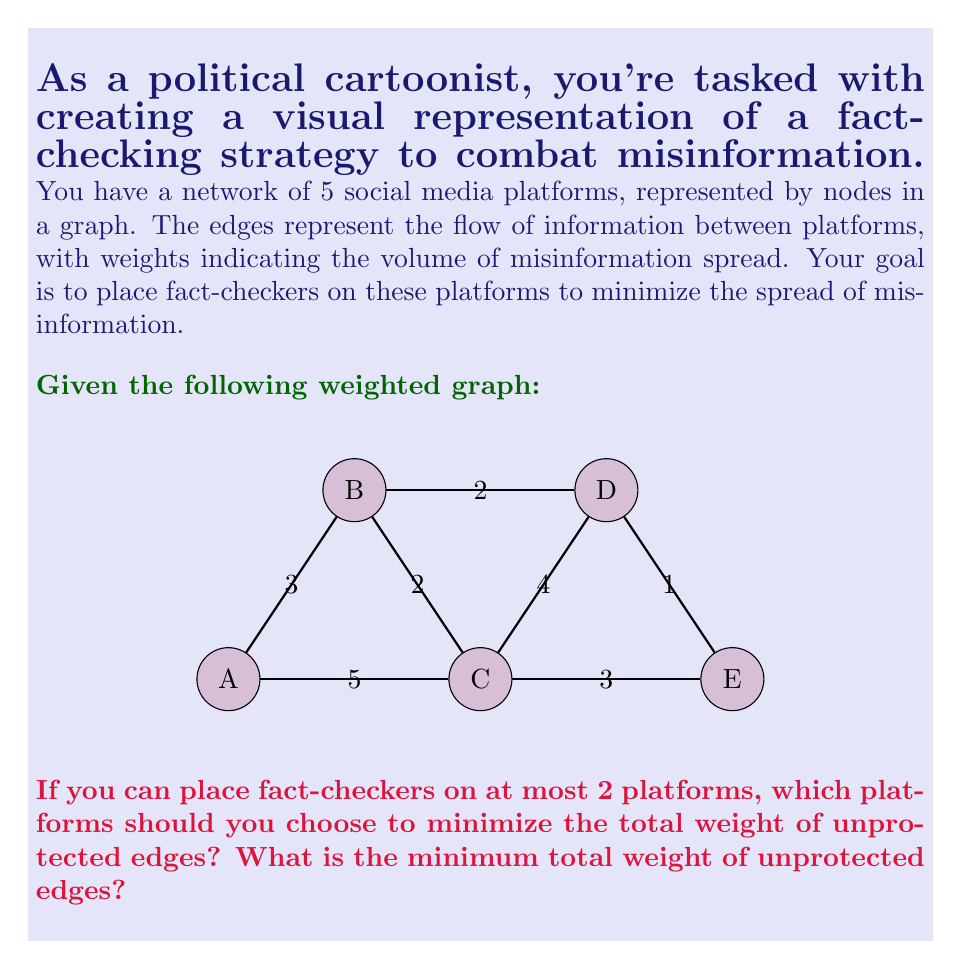Can you answer this question? Let's approach this step-by-step:

1) First, we need to understand what "unprotected edges" means. An edge is considered protected if at least one of its endpoints (nodes) has a fact-checker.

2) We need to consider all possible combinations of placing fact-checkers on 2 platforms out of 5. There are $\binom{5}{2} = 10$ such combinations.

3) For each combination, we'll calculate the total weight of unprotected edges:

   AB: 3-2 = 1 (BC, CD, DE unprotected)
   AC: 3+2+1 = 6 (BD, DE unprotected)
   AD: 3+5+3+1 = 12 (BC, CE unprotected)
   AE: 3+2+4+2 = 11 (BC, BD unprotected)
   BC: 3+4+1 = 8 (AE unprotected)
   BD: 3+5+3+1 = 12 (AC, CE unprotected)
   BE: 3+5+4+2 = 14 (AC unprotected)
   CD: 3+5+1 = 9 (AB, DE unprotected)
   CE: 3+2+2 = 7 (AB, BD unprotected)
   DE: 3+5+4+2 = 14 (AC unprotected)

4) The minimum total weight of unprotected edges is 1, which occurs when fact-checkers are placed on platforms A and B.

5) This makes sense intuitively as well, since A and B are connected to the edges with the highest weights (5 and 3).
Answer: Platforms A and B; 1 